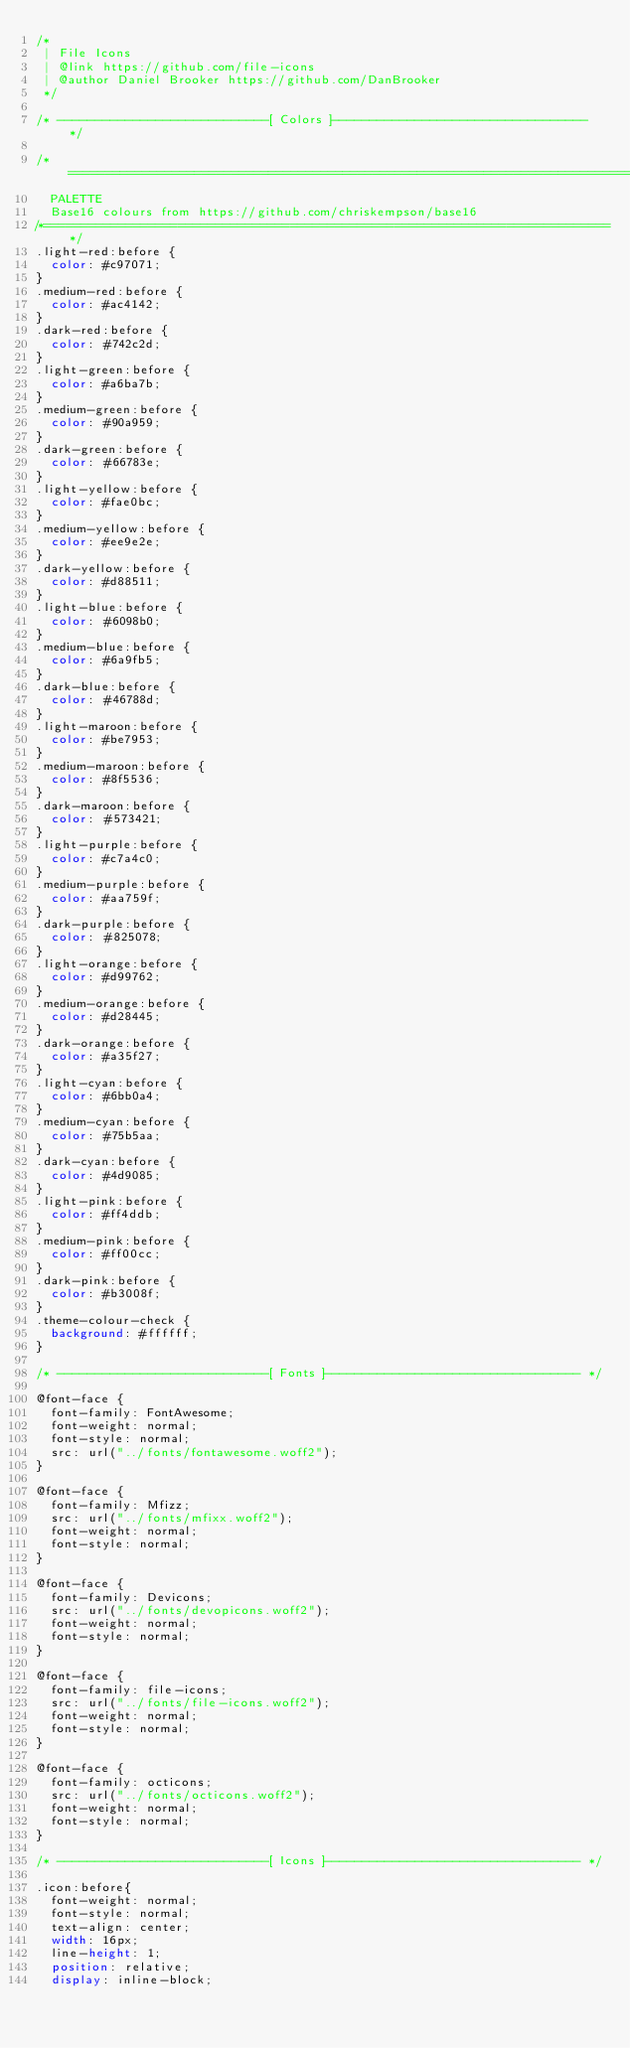<code> <loc_0><loc_0><loc_500><loc_500><_CSS_>/*
 | File Icons
 | @link https://github.com/file-icons
 | @author Daniel Brooker https://github.com/DanBrooker
 */

/* ----------------------------[ Colors ]---------------------------------- */

/*============================================================================*
	PALETTE
	Base16 colours from https://github.com/chriskempson/base16
/*============================================================================*/
.light-red:before {
  color: #c97071;
}
.medium-red:before {
  color: #ac4142;
}
.dark-red:before {
  color: #742c2d;
}
.light-green:before {
  color: #a6ba7b;
}
.medium-green:before {
  color: #90a959;
}
.dark-green:before {
  color: #66783e;
}
.light-yellow:before {
  color: #fae0bc;
}
.medium-yellow:before {
  color: #ee9e2e;
}
.dark-yellow:before {
  color: #d88511;
}
.light-blue:before {
  color: #6098b0;
}
.medium-blue:before {
  color: #6a9fb5;
}
.dark-blue:before {
  color: #46788d;
}
.light-maroon:before {
  color: #be7953;
}
.medium-maroon:before {
  color: #8f5536;
}
.dark-maroon:before {
  color: #573421;
}
.light-purple:before {
  color: #c7a4c0;
}
.medium-purple:before {
  color: #aa759f;
}
.dark-purple:before {
  color: #825078;
}
.light-orange:before {
  color: #d99762;
}
.medium-orange:before {
  color: #d28445;
}
.dark-orange:before {
  color: #a35f27;
}
.light-cyan:before {
  color: #6bb0a4;
}
.medium-cyan:before {
  color: #75b5aa;
}
.dark-cyan:before {
  color: #4d9085;
}
.light-pink:before {
  color: #ff4ddb;
}
.medium-pink:before {
  color: #ff00cc;
}
.dark-pink:before {
  color: #b3008f;
}
.theme-colour-check {
  background: #ffffff;
}

/* ----------------------------[ Fonts ]---------------------------------- */

@font-face {
	font-family: FontAwesome;
	font-weight: normal;
	font-style: normal;
	src: url("../fonts/fontawesome.woff2");
}

@font-face {
	font-family: Mfizz;
	src: url("../fonts/mfixx.woff2");
	font-weight: normal;
	font-style: normal;
}

@font-face {
	font-family: Devicons;
	src: url("../fonts/devopicons.woff2");
	font-weight: normal;
	font-style: normal;
}

@font-face {
	font-family: file-icons;
	src: url("../fonts/file-icons.woff2");
	font-weight: normal;
	font-style: normal;
}

@font-face {
	font-family: octicons;
	src: url("../fonts/octicons.woff2");
	font-weight: normal;
	font-style: normal;
}

/* ----------------------------[ Icons ]---------------------------------- */

.icon:before{
	font-weight: normal;
	font-style: normal;
	text-align: center;
	width: 16px;
	line-height: 1;
	position: relative;
	display: inline-block;</code> 